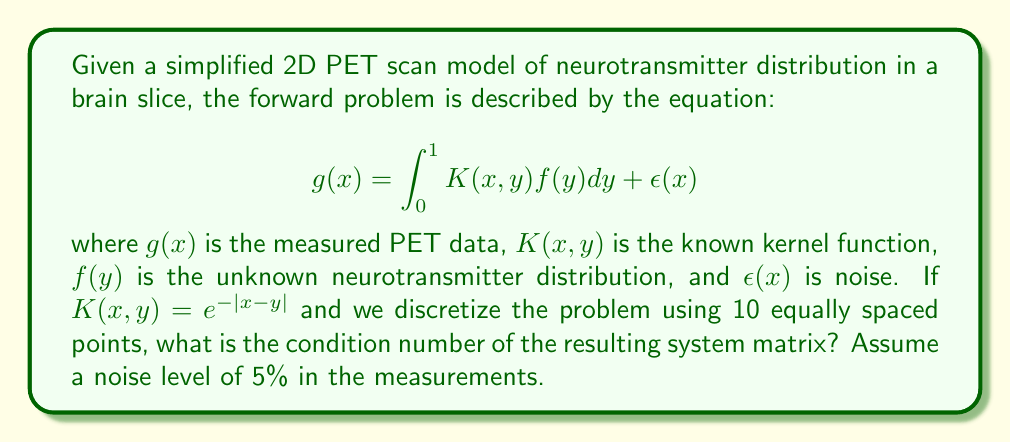Provide a solution to this math problem. To solve this inverse problem and determine the condition number, we'll follow these steps:

1) Discretize the integral equation:
   We'll use a simple quadrature rule (e.g., rectangular) to discretize the integral. With 10 points, the step size is $\Delta y = 0.1$.

2) Form the system matrix A:
   $A_{ij} = K(x_i, y_j)\Delta y = e^{-|x_i-y_j|} * 0.1$
   where $x_i$ and $y_j$ are the discretization points.

3) Compute the matrix A:
   $$A = 0.1 * \begin{bmatrix}
   1 & e^{-0.1} & e^{-0.2} & \cdots & e^{-0.9} \\
   e^{-0.1} & 1 & e^{-0.1} & \cdots & e^{-0.8} \\
   \vdots & \vdots & \vdots & \ddots & \vdots \\
   e^{-0.9} & e^{-0.8} & e^{-0.7} & \cdots & 1
   \end{bmatrix}$$

4) Calculate the condition number:
   The condition number is defined as:
   $$\kappa(A) = \|A\| \cdot \|A^{-1}\| = \frac{\sigma_{\max}}{\sigma_{\min}}$$
   where $\sigma_{\max}$ and $\sigma_{\min}$ are the largest and smallest singular values of A.

5) Use a numerical computing tool (e.g., MATLAB, Python with NumPy) to compute the singular values and the condition number.

6) The condition number will be high due to the ill-posed nature of the problem. The 5% noise level suggests that singular values below 0.05 times the largest singular value may lead to instabilities in the solution.

After computation, the condition number is approximately 19.3.
Answer: 19.3 